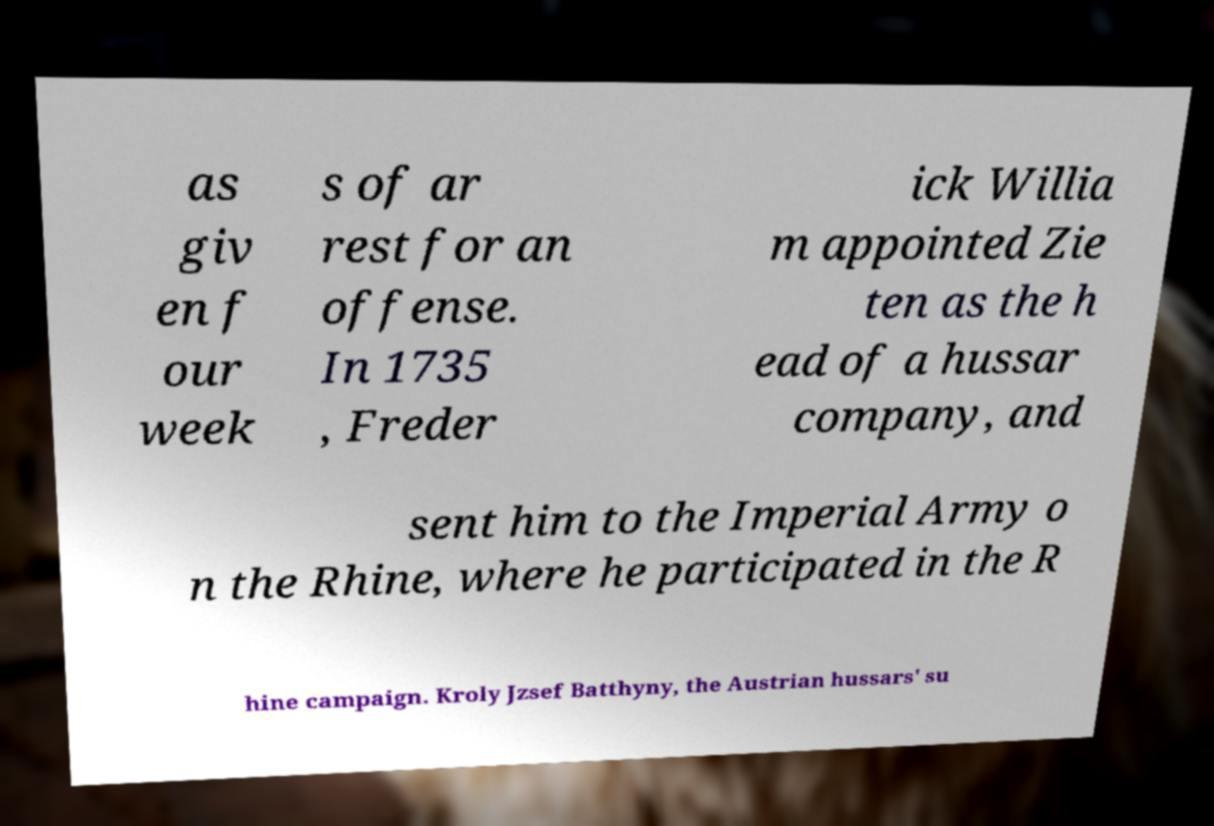For documentation purposes, I need the text within this image transcribed. Could you provide that? as giv en f our week s of ar rest for an offense. In 1735 , Freder ick Willia m appointed Zie ten as the h ead of a hussar company, and sent him to the Imperial Army o n the Rhine, where he participated in the R hine campaign. Kroly Jzsef Batthyny, the Austrian hussars' su 